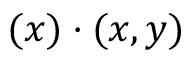Convert formula to latex. <formula><loc_0><loc_0><loc_500><loc_500>( x ) \cdot ( x , y )</formula> 